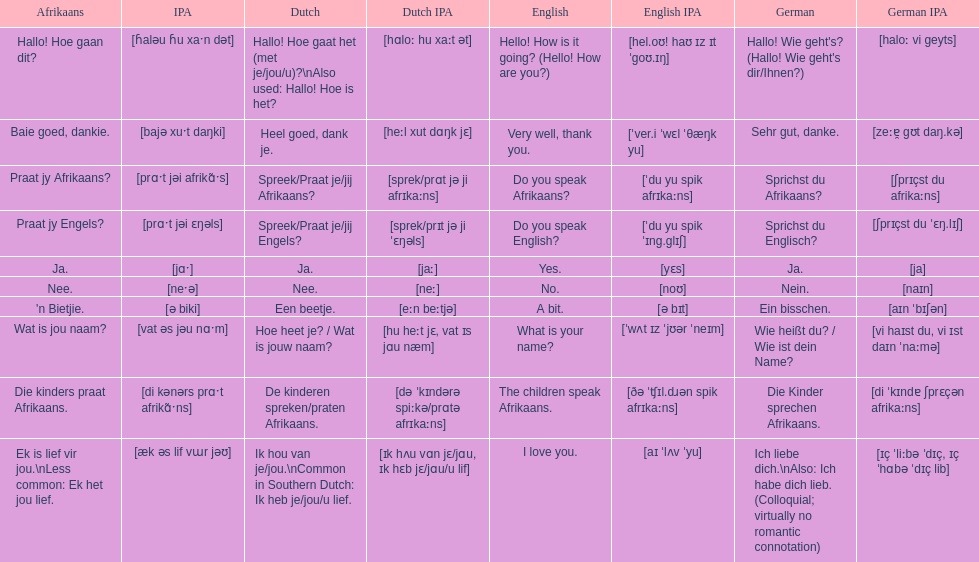How do you say "do you speak afrikaans?" in afrikaans? Praat jy Afrikaans?. 